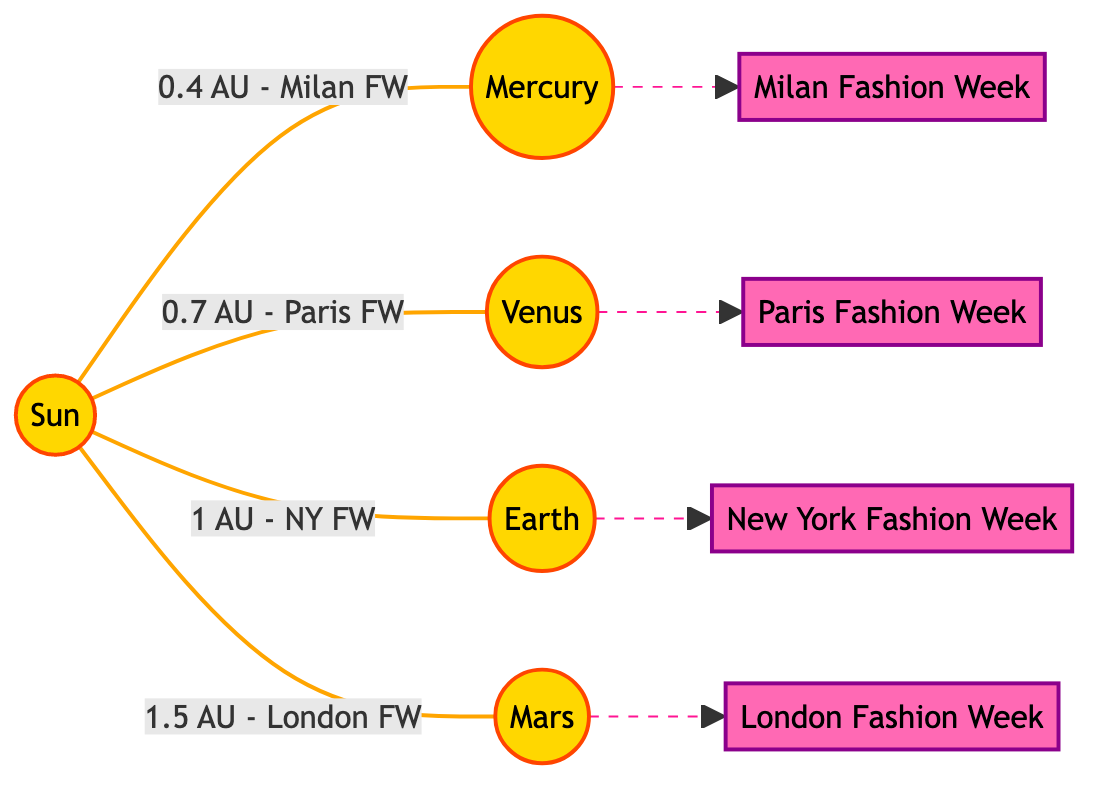What is the distance of Venus from the Sun in the diagram? The diagram indicates that Venus is connected to the Sun with a label showing a distance of 0.7 AU. This means that the distance of Venus from the Sun is specifically stated in the diagram.
Answer: 0.7 AU Which planet is closest to the Sun according to the diagram? The diagram lists Mercury connected to the Sun and is the first node in the sequence, indicating it is the closest planet to the Sun.
Answer: Mercury How many fashion events are represented in the diagram? The diagram shows four distinct fashion events: Milan Fashion Week, Paris Fashion Week, New York Fashion Week, and London Fashion Week. Counting these events gives a total of four.
Answer: 4 What is the distance of Earth from the Sun as indicated in the diagram? The diagram states that the distance from the Sun to Earth is labeled as 1 AU. This is the direct information visible in the visual connection between the Sun and Earth.
Answer: 1 AU Which fashion event is associated with Mars? The diagram illustrates a dashed line from Mars to London Fashion Week, showing that this particular fashion event is aligned with Mars according to the representation.
Answer: London Fashion Week What type of line connects Mercury to Milan Fashion Week? The diagram uses a solid line connecting Mercury to Milan Fashion Week, which shows a direct relationship between these two elements. Solid lines typically indicate a clear association or connection.
Answer: Solid line What is the relative distance from the Sun to Mars compared to Earth? The diagram indicates that Mars is at a distance of 1.5 AU from the Sun while Earth is at 1 AU. This means Mars is 0.5 AU farther from the Sun than Earth is, highlighting their relative positions.
Answer: 0.5 AU farther Which planet is depicted to have the furthest connection to a fashion event? The diagram shows that Mars, being 1.5 AU from the Sun, has the furthest connection to a fashion event, specifically London Fashion Week. Thus, Mars is highlighted as the farthest planet linked to any major fashion show.
Answer: Mars What color represents the planets in the diagram? The planets in the diagram are filled with a gold color, as indicated by the color code specified in the class definition for planets. This unique color distinguishes them visually from the fashion events.
Answer: Gold 